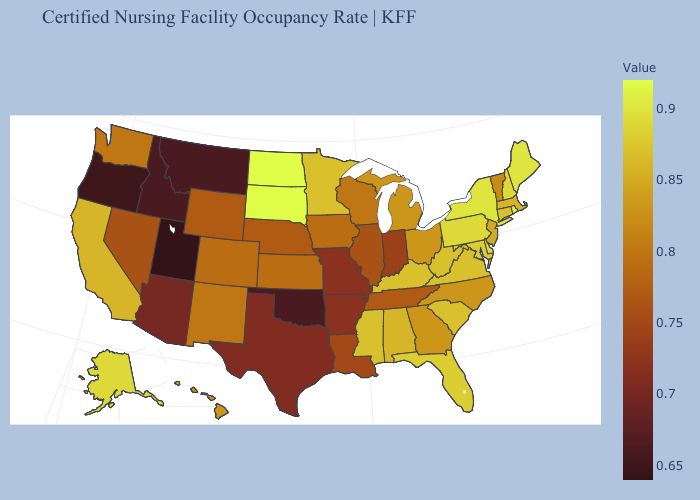Which states have the highest value in the USA?
Be succinct. North Dakota, South Dakota. Which states have the highest value in the USA?
Be succinct. North Dakota, South Dakota. Which states have the lowest value in the West?
Short answer required. Utah. Is the legend a continuous bar?
Quick response, please. Yes. Does New Jersey have a lower value than Pennsylvania?
Quick response, please. Yes. 